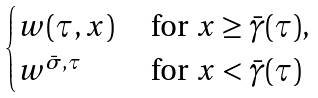Convert formula to latex. <formula><loc_0><loc_0><loc_500><loc_500>\begin{cases} w ( \tau , x ) & \text { for } x \geq \bar { \gamma } ( \tau ) , \\ w ^ { \bar { \sigma } , \tau } & \text { for } x < \bar { \gamma } ( \tau ) \end{cases}</formula> 